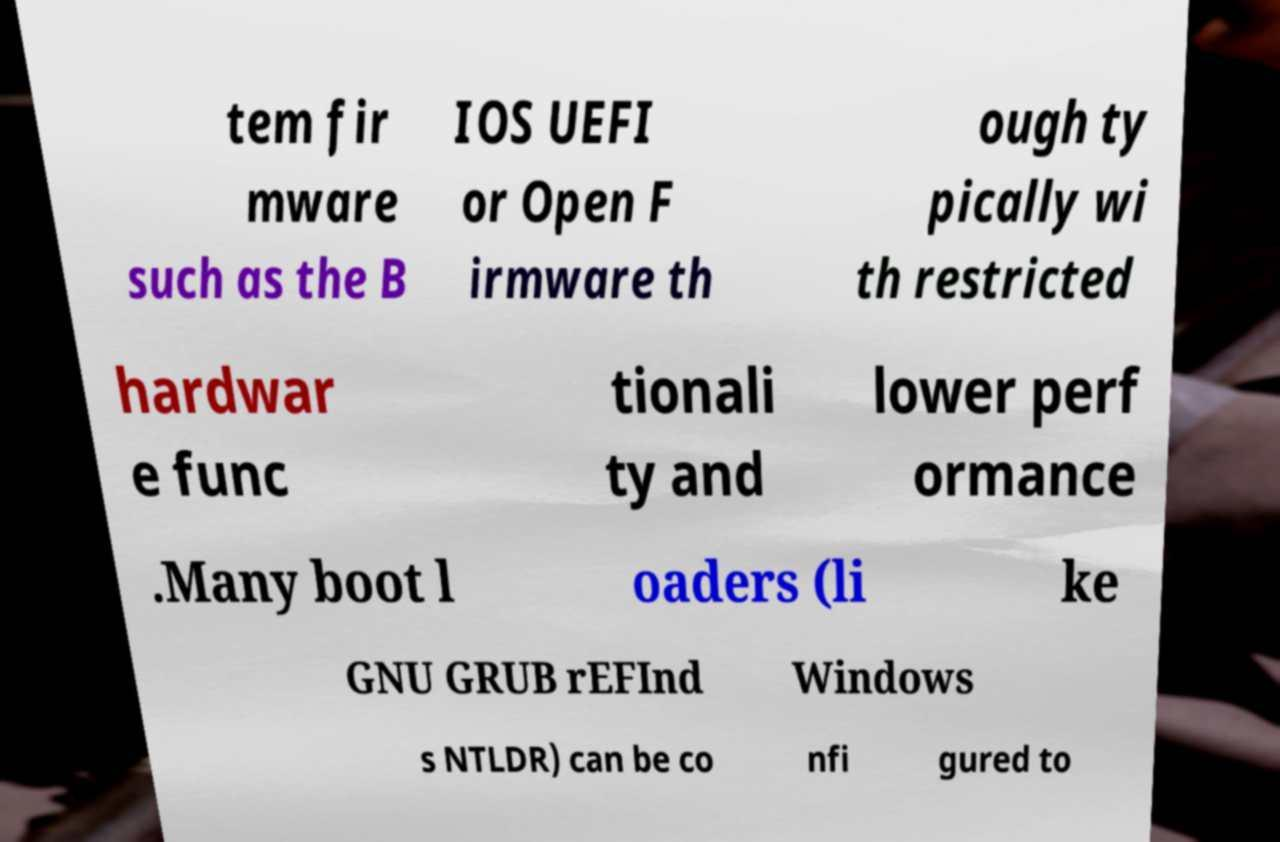Could you assist in decoding the text presented in this image and type it out clearly? tem fir mware such as the B IOS UEFI or Open F irmware th ough ty pically wi th restricted hardwar e func tionali ty and lower perf ormance .Many boot l oaders (li ke GNU GRUB rEFInd Windows s NTLDR) can be co nfi gured to 